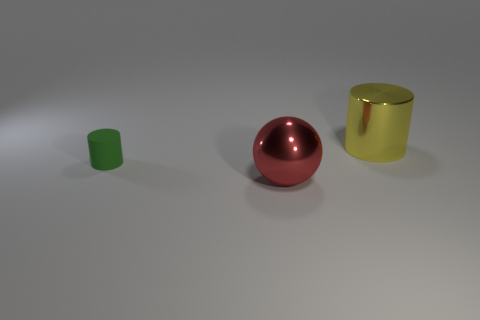Add 3 metal cylinders. How many objects exist? 6 Subtract all cylinders. How many objects are left? 1 Add 2 tiny matte cylinders. How many tiny matte cylinders exist? 3 Subtract 0 blue blocks. How many objects are left? 3 Subtract all big metallic objects. Subtract all big yellow things. How many objects are left? 0 Add 1 red things. How many red things are left? 2 